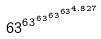Convert formula to latex. <formula><loc_0><loc_0><loc_500><loc_500>6 3 ^ { 6 3 ^ { 6 3 ^ { 6 3 ^ { 6 3 ^ { 4 . 8 2 7 } } } } }</formula> 